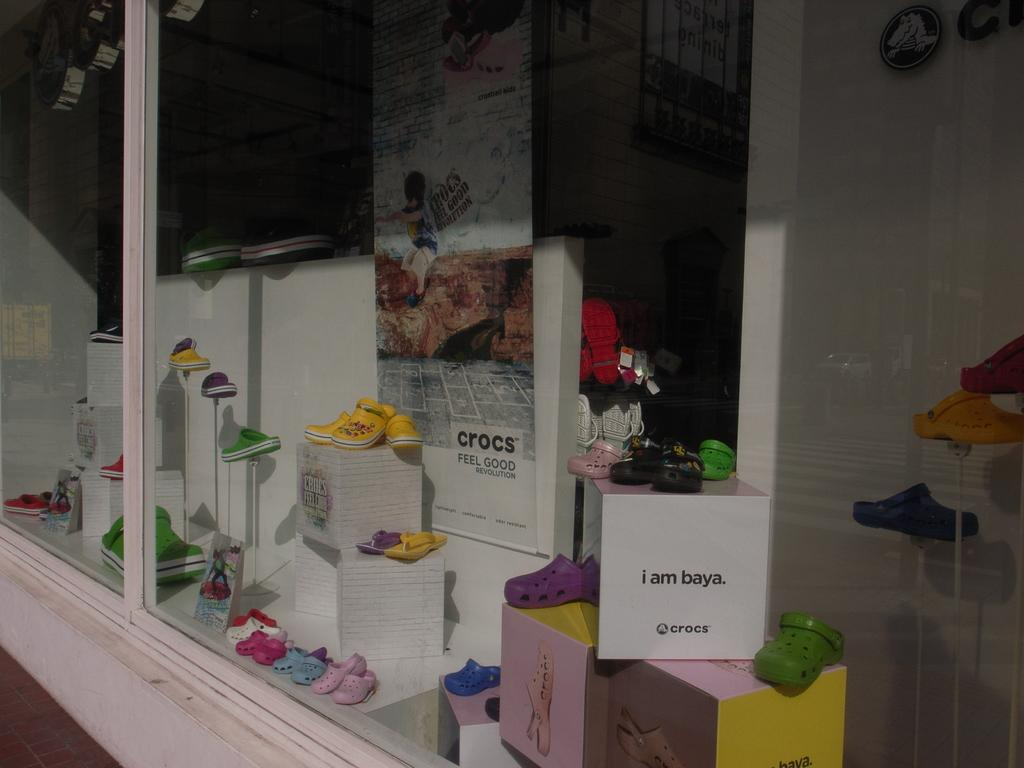<image>
Give a short and clear explanation of the subsequent image. Display showing Crocs shoes and the phrase "i am baya". 